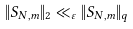Convert formula to latex. <formula><loc_0><loc_0><loc_500><loc_500>\| S _ { N , m } \| _ { 2 } \ll _ { \varepsilon } \| S _ { N , m } \| _ { q }</formula> 